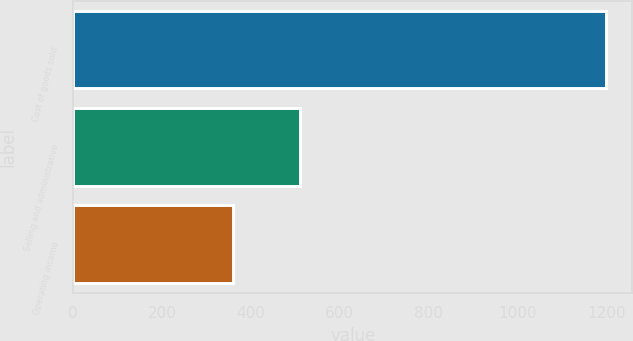Convert chart to OTSL. <chart><loc_0><loc_0><loc_500><loc_500><bar_chart><fcel>Cost of goods sold<fcel>Selling and administrative<fcel>Operating income<nl><fcel>1199<fcel>510.5<fcel>358.6<nl></chart> 